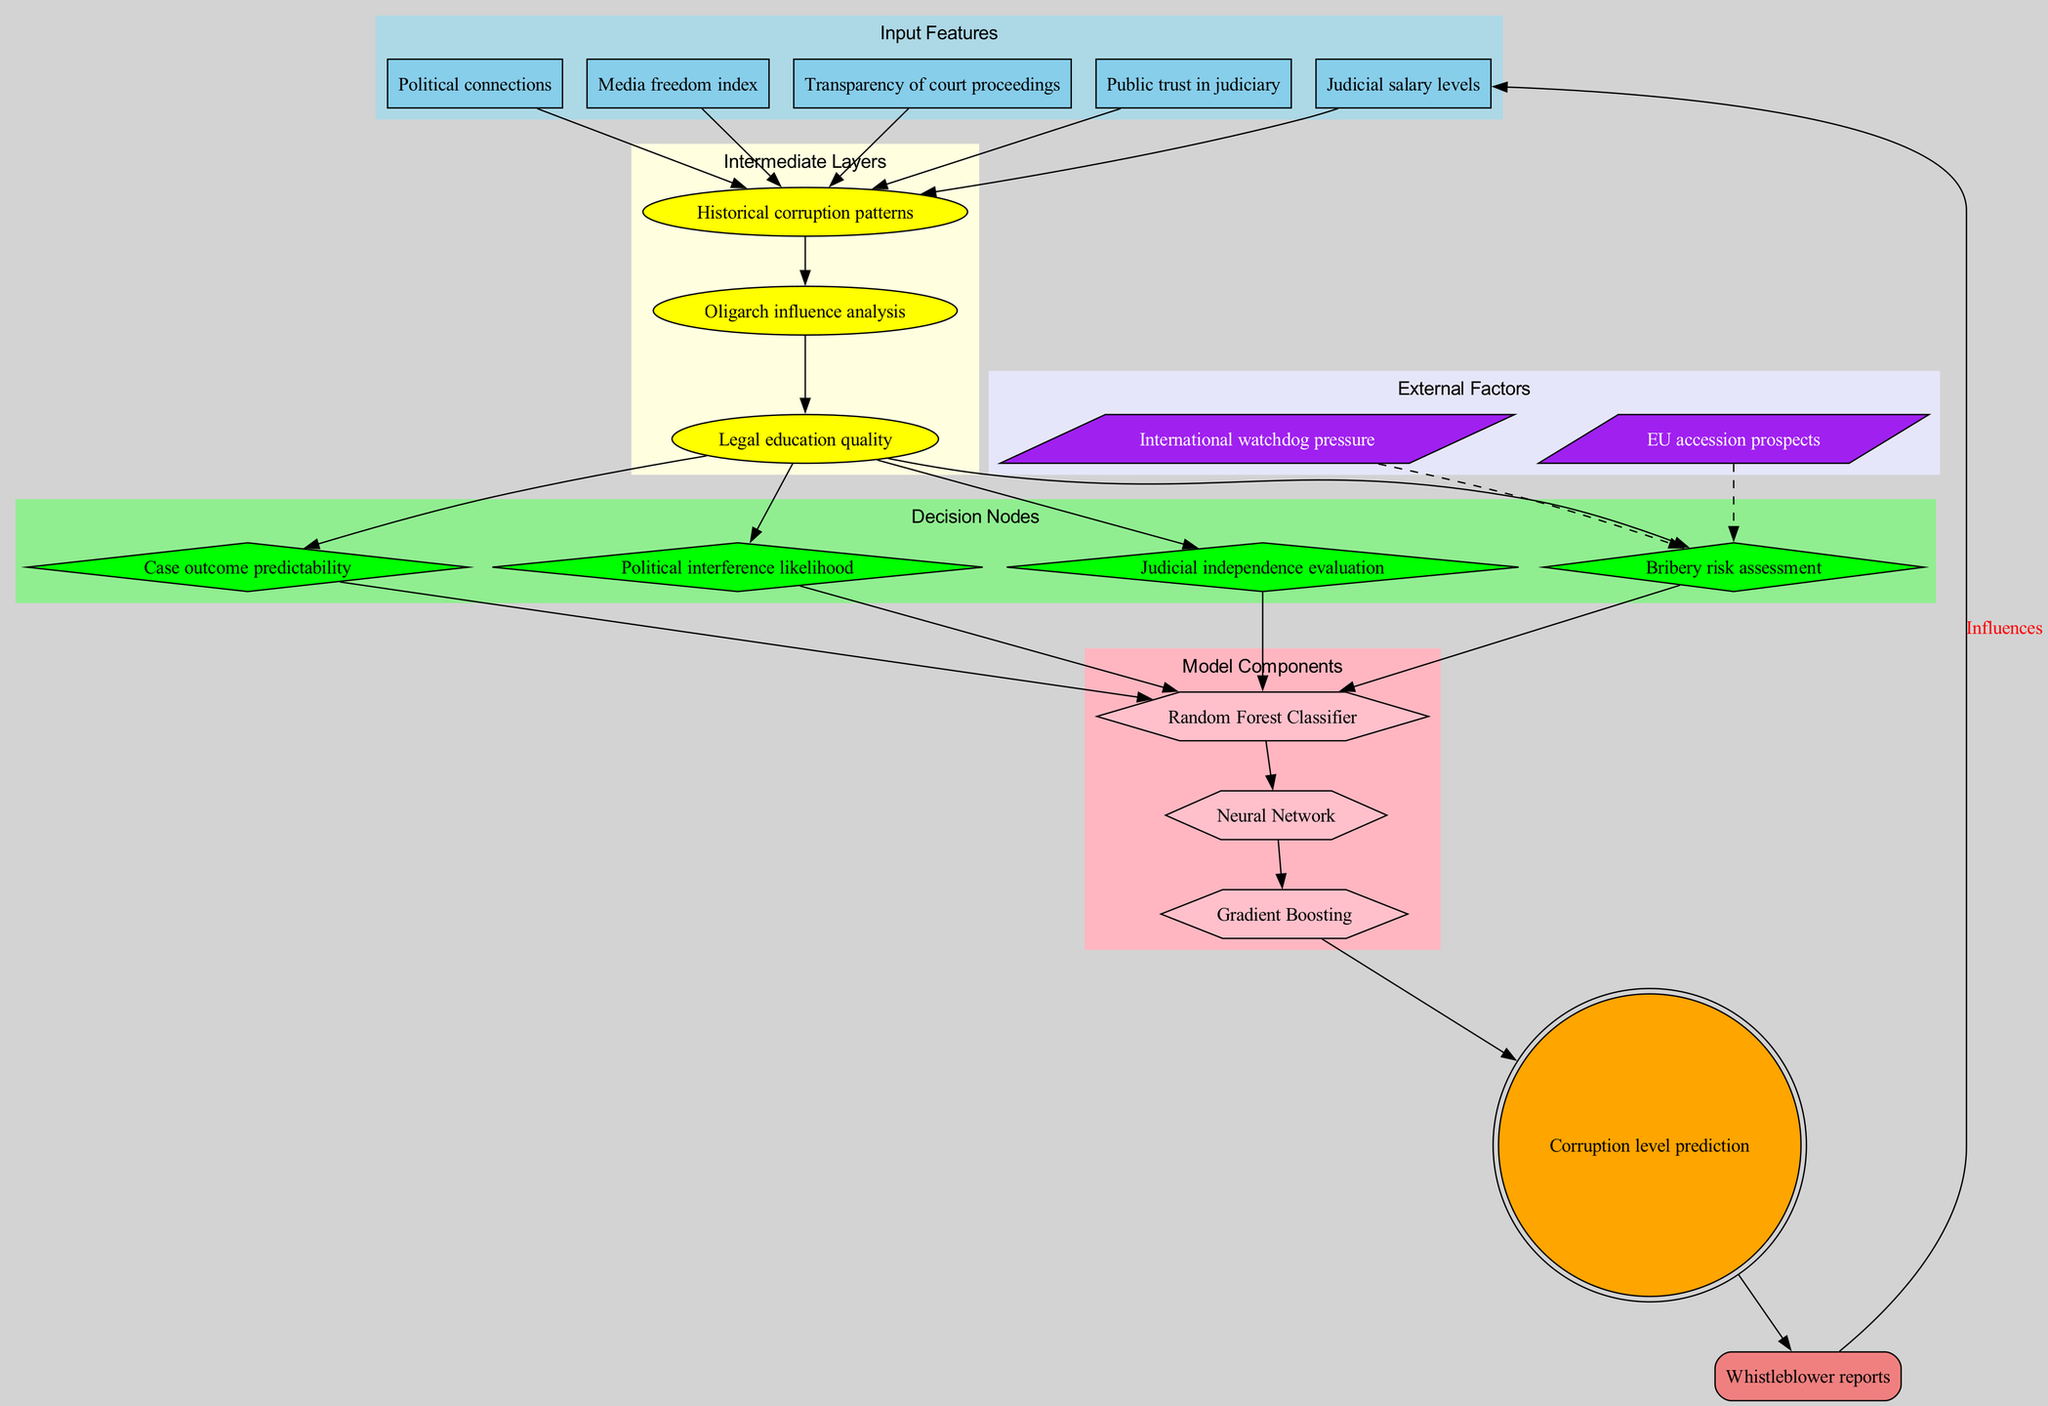What are the input features in this model? The input features are listed in a cluster within the diagram, showing five specific aspects that influence the corruption level prediction. These features include "Judicial salary levels," "Political connections," "Media freedom index," "Transparency of court proceedings," and "Public trust in judiciary."
Answer: Judicial salary levels, Political connections, Media freedom index, Transparency of court proceedings, Public trust in judiciary How many decision nodes are present? Each decision node is represented by a diamond-shaped node in the diagram. By counting all the nodes in the 'Decision Nodes' cluster, there are four decision nodes: "Bribery risk assessment," "Political interference likelihood," "Judicial independence evaluation," and "Case outcome predictability."
Answer: Four Which model component connects to the output? The output node, which predicts corruption levels, is connected directly from the last model component represented in the diagram. By reviewing the edges, we can see that the final model component connected before the output is "Gradient Boosting."
Answer: Gradient Boosting How do external factors influence decision nodes? The external factors are visually depicted as a separate cluster with dashed edges connecting to the first decision node, indicating non-direct influences. These factors include "EU accession prospects" and "International watchdog pressure," influencing the "Bribery risk assessment" decision node.
Answer: Bribery risk assessment What is the feedback loop in the diagram? The feedback loop is illustrated by a box labeled "Whistleblower reports," which indicates the return influence on the input features, showing how reports potentially affect the inputs of the model. The connection leads back to influence "Judicial salary levels".
Answer: Whistleblower reports What is the connection between historical corruption patterns and decision nodes? The edges in the diagram link "Historical corruption patterns" to the first decision node, establishing a direct pathway that demonstrates how historical data informs the "Bribery risk assessment," thus indicating its influence on the model's predictions.
Answer: Bribery risk assessment 